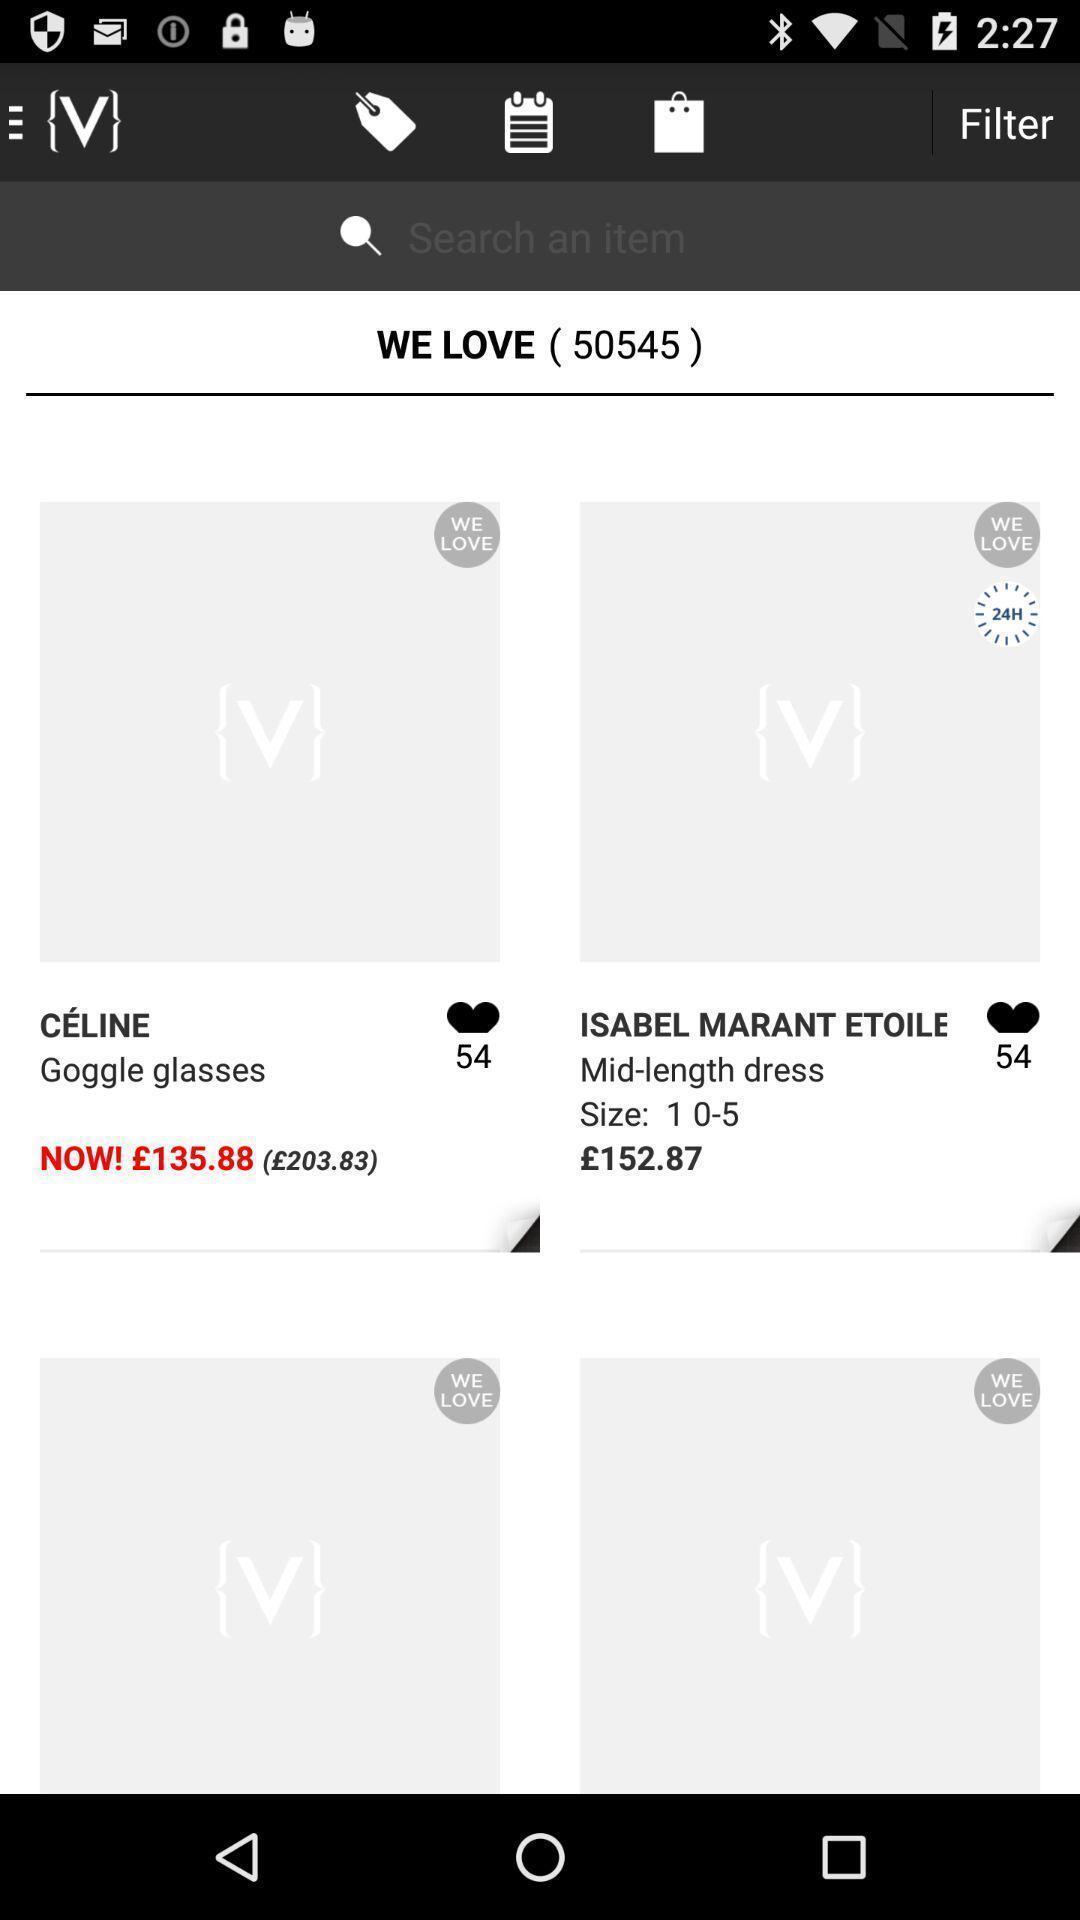Describe the visual elements of this screenshot. Shopping page displaying price and details of products. 